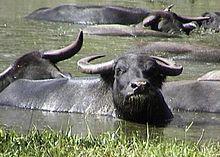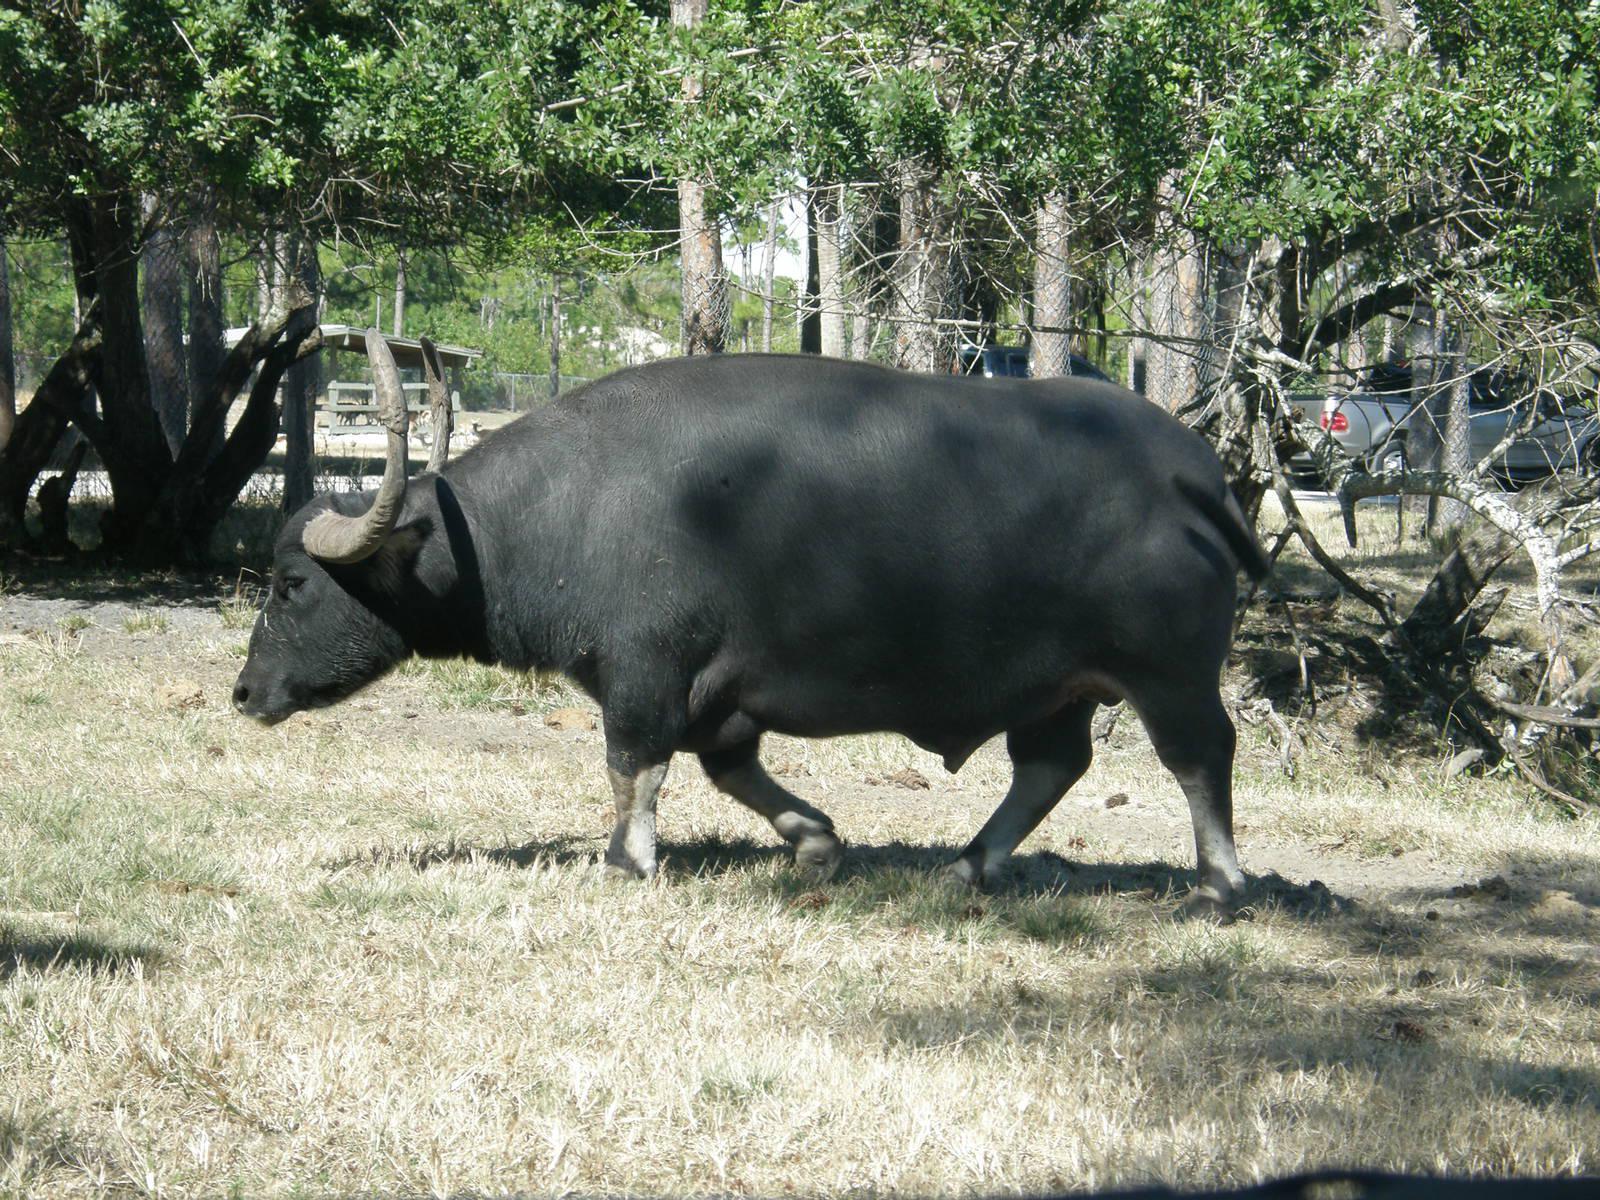The first image is the image on the left, the second image is the image on the right. Examine the images to the left and right. Is the description "One image shows just one ox, and it has rope threaded through its nose." accurate? Answer yes or no. No. 